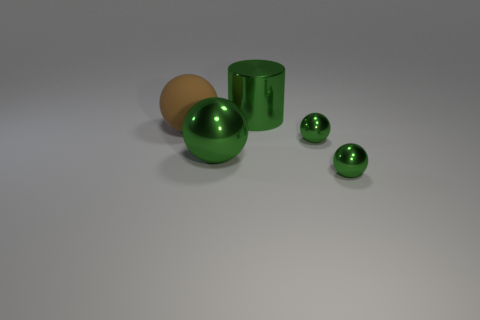Subtract all yellow cylinders. How many green spheres are left? 3 Add 1 green shiny balls. How many objects exist? 6 Subtract all balls. How many objects are left? 1 Subtract 0 yellow cylinders. How many objects are left? 5 Subtract all big spheres. Subtract all small green metallic objects. How many objects are left? 1 Add 5 big brown things. How many big brown things are left? 6 Add 4 green spheres. How many green spheres exist? 7 